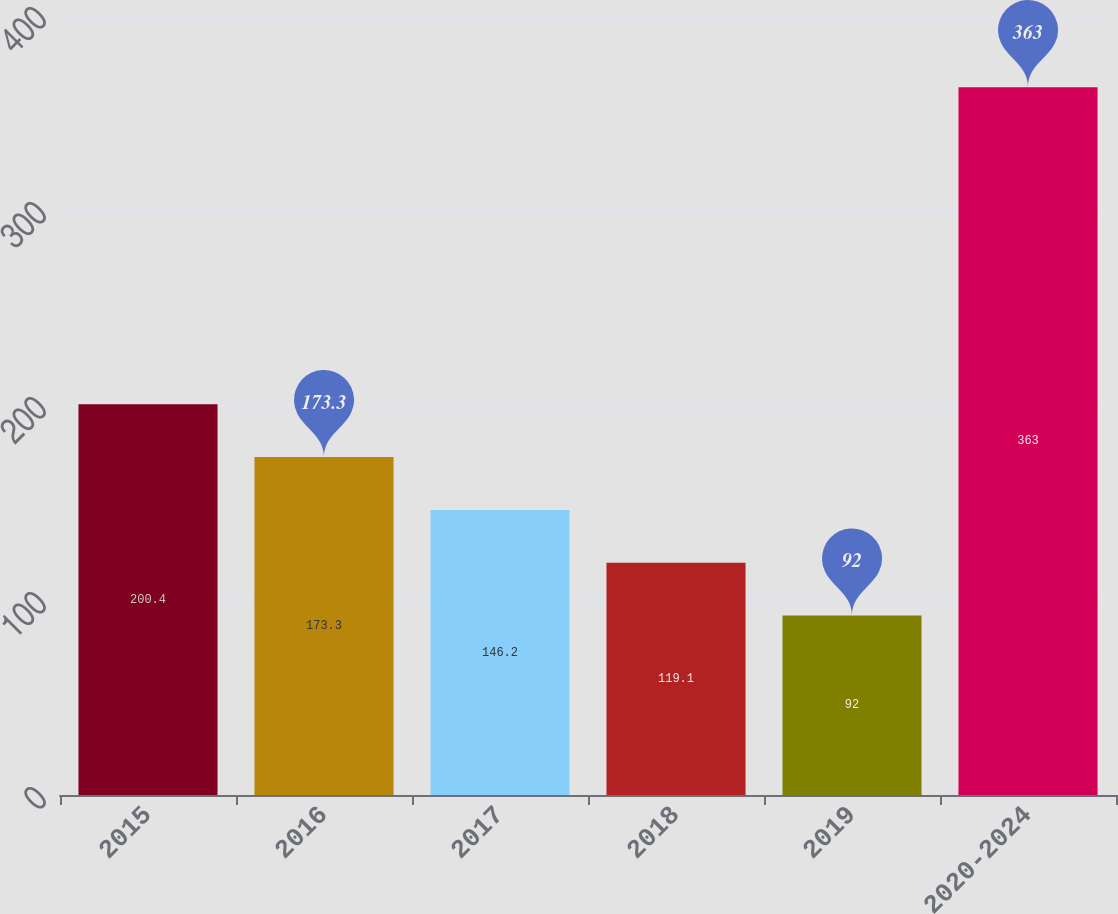<chart> <loc_0><loc_0><loc_500><loc_500><bar_chart><fcel>2015<fcel>2016<fcel>2017<fcel>2018<fcel>2019<fcel>2020-2024<nl><fcel>200.4<fcel>173.3<fcel>146.2<fcel>119.1<fcel>92<fcel>363<nl></chart> 